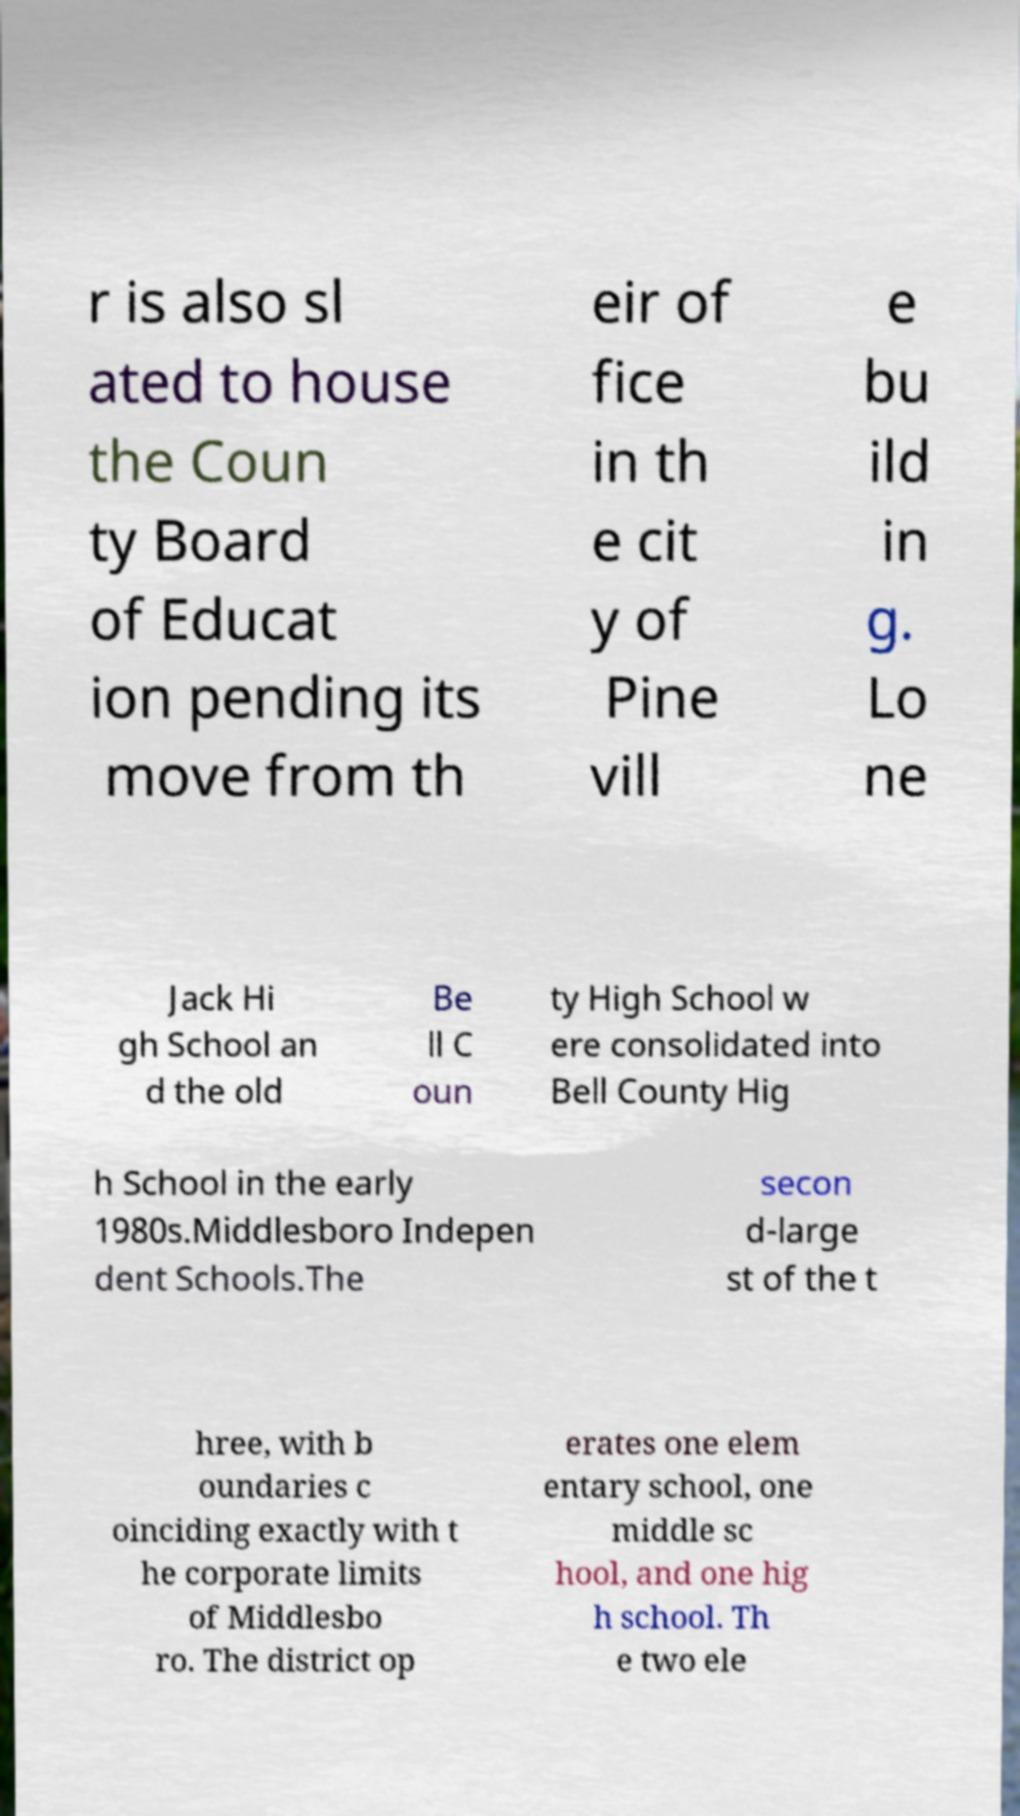Please read and relay the text visible in this image. What does it say? r is also sl ated to house the Coun ty Board of Educat ion pending its move from th eir of fice in th e cit y of Pine vill e bu ild in g. Lo ne Jack Hi gh School an d the old Be ll C oun ty High School w ere consolidated into Bell County Hig h School in the early 1980s.Middlesboro Indepen dent Schools.The secon d-large st of the t hree, with b oundaries c oinciding exactly with t he corporate limits of Middlesbo ro. The district op erates one elem entary school, one middle sc hool, and one hig h school. Th e two ele 